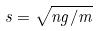Convert formula to latex. <formula><loc_0><loc_0><loc_500><loc_500>s = \sqrt { n g / m }</formula> 